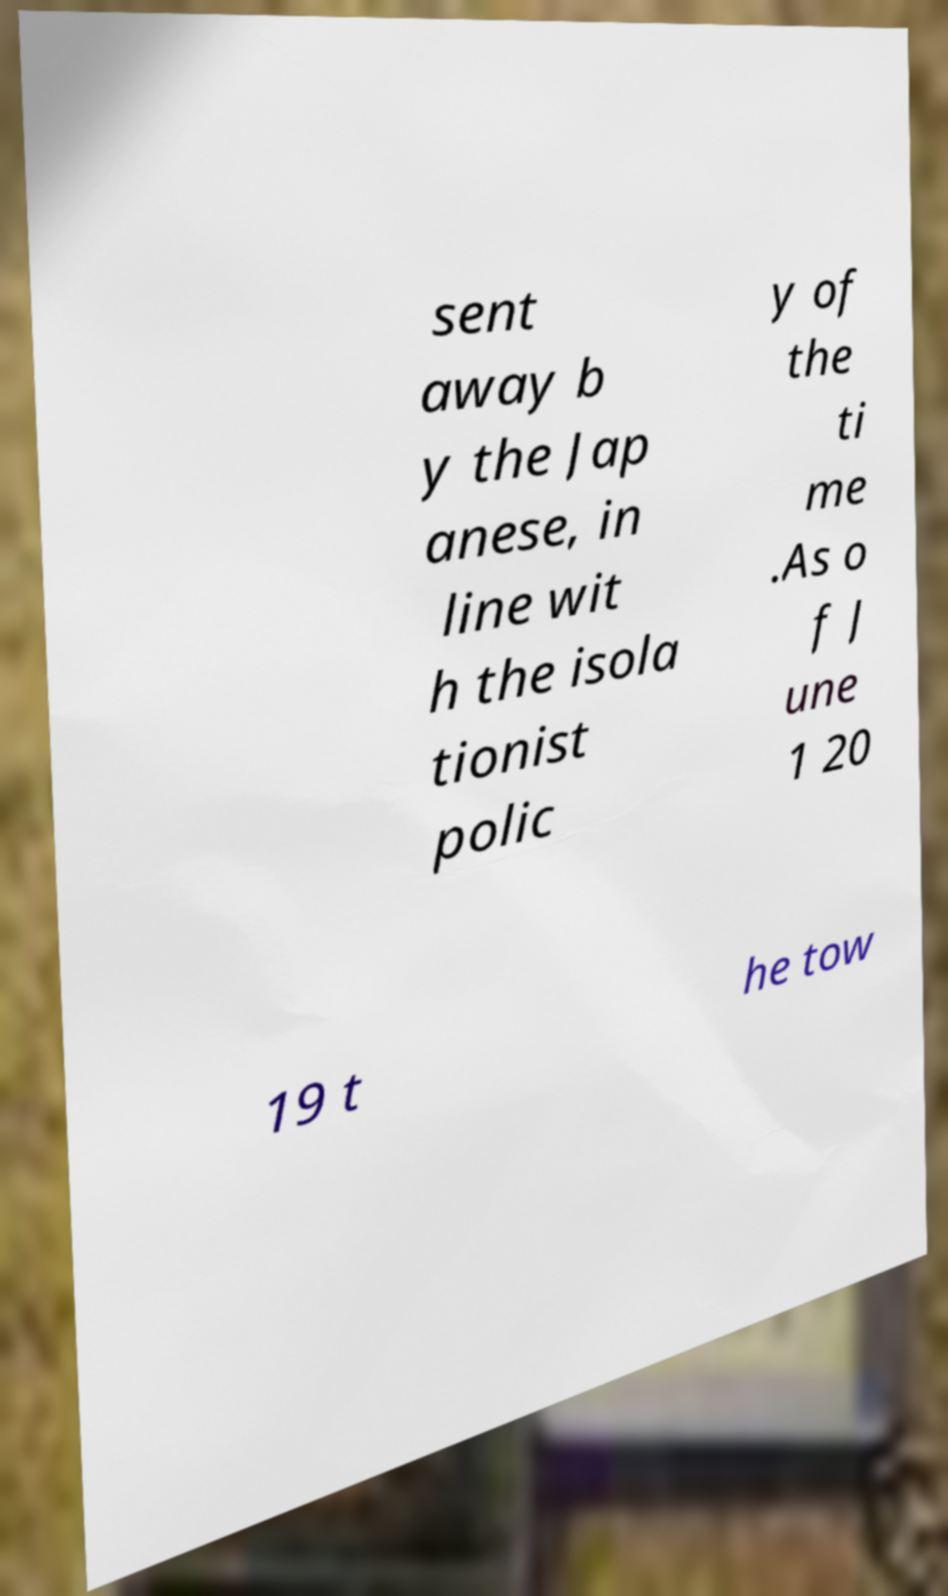I need the written content from this picture converted into text. Can you do that? sent away b y the Jap anese, in line wit h the isola tionist polic y of the ti me .As o f J une 1 20 19 t he tow 